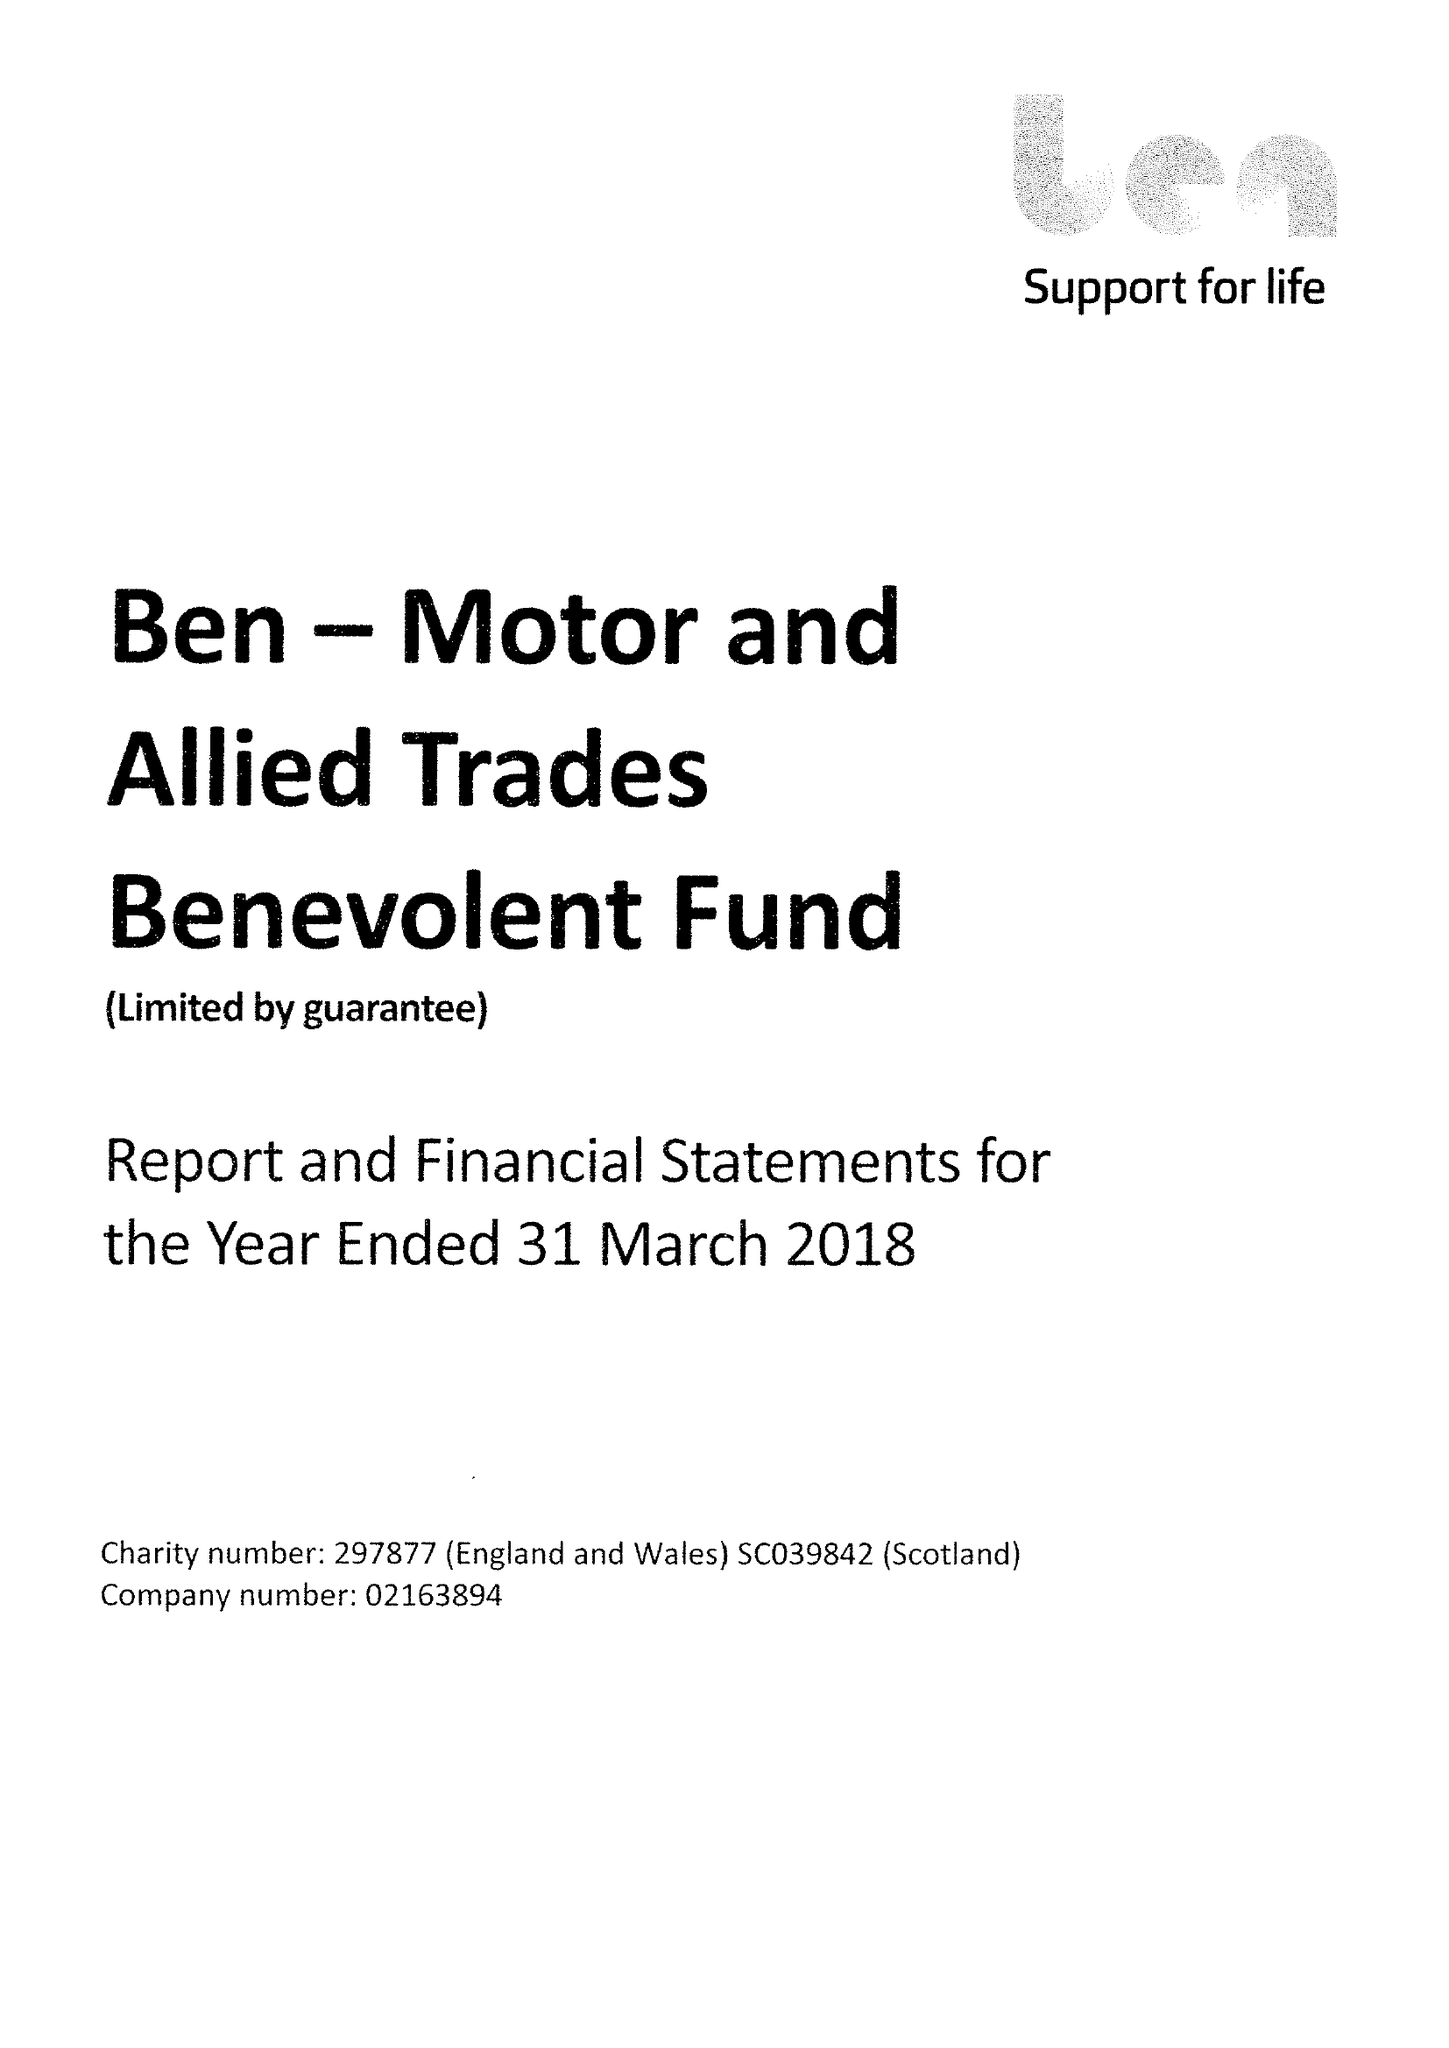What is the value for the address__postcode?
Answer the question using a single word or phrase. SL5 0FG 